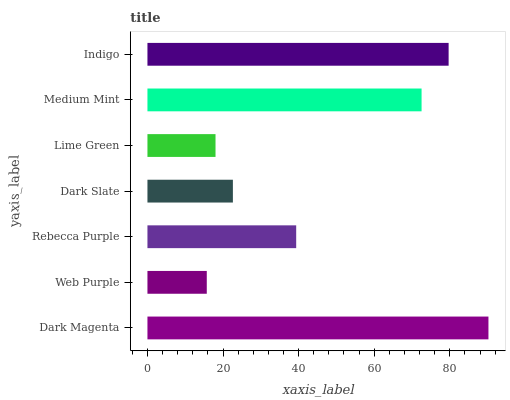Is Web Purple the minimum?
Answer yes or no. Yes. Is Dark Magenta the maximum?
Answer yes or no. Yes. Is Rebecca Purple the minimum?
Answer yes or no. No. Is Rebecca Purple the maximum?
Answer yes or no. No. Is Rebecca Purple greater than Web Purple?
Answer yes or no. Yes. Is Web Purple less than Rebecca Purple?
Answer yes or no. Yes. Is Web Purple greater than Rebecca Purple?
Answer yes or no. No. Is Rebecca Purple less than Web Purple?
Answer yes or no. No. Is Rebecca Purple the high median?
Answer yes or no. Yes. Is Rebecca Purple the low median?
Answer yes or no. Yes. Is Indigo the high median?
Answer yes or no. No. Is Dark Magenta the low median?
Answer yes or no. No. 